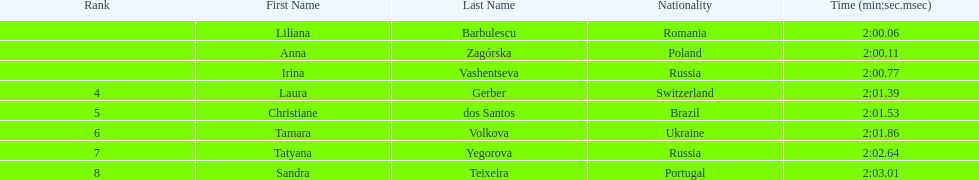Which south american country placed after irina vashentseva? Brazil. 